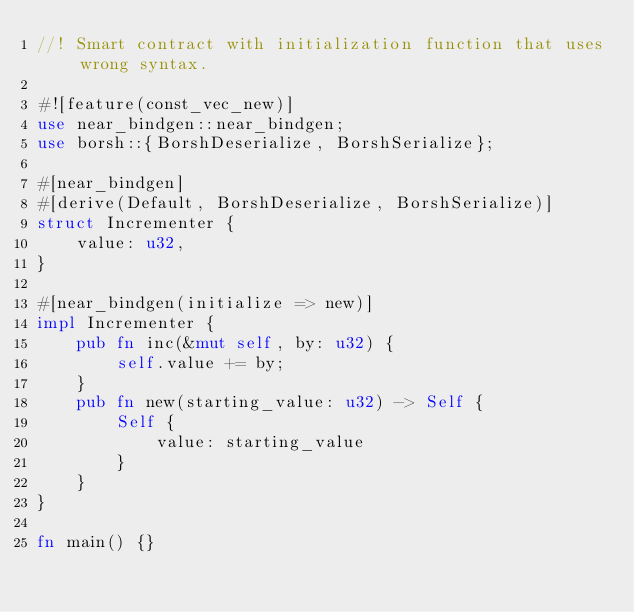<code> <loc_0><loc_0><loc_500><loc_500><_Rust_>//! Smart contract with initialization function that uses wrong syntax.

#![feature(const_vec_new)]
use near_bindgen::near_bindgen;
use borsh::{BorshDeserialize, BorshSerialize};

#[near_bindgen]
#[derive(Default, BorshDeserialize, BorshSerialize)]
struct Incrementer {
    value: u32,
}

#[near_bindgen(initialize => new)]
impl Incrementer {
    pub fn inc(&mut self, by: u32) {
        self.value += by;
    }
    pub fn new(starting_value: u32) -> Self {
        Self {
            value: starting_value
        }
    }
}

fn main() {}
</code> 